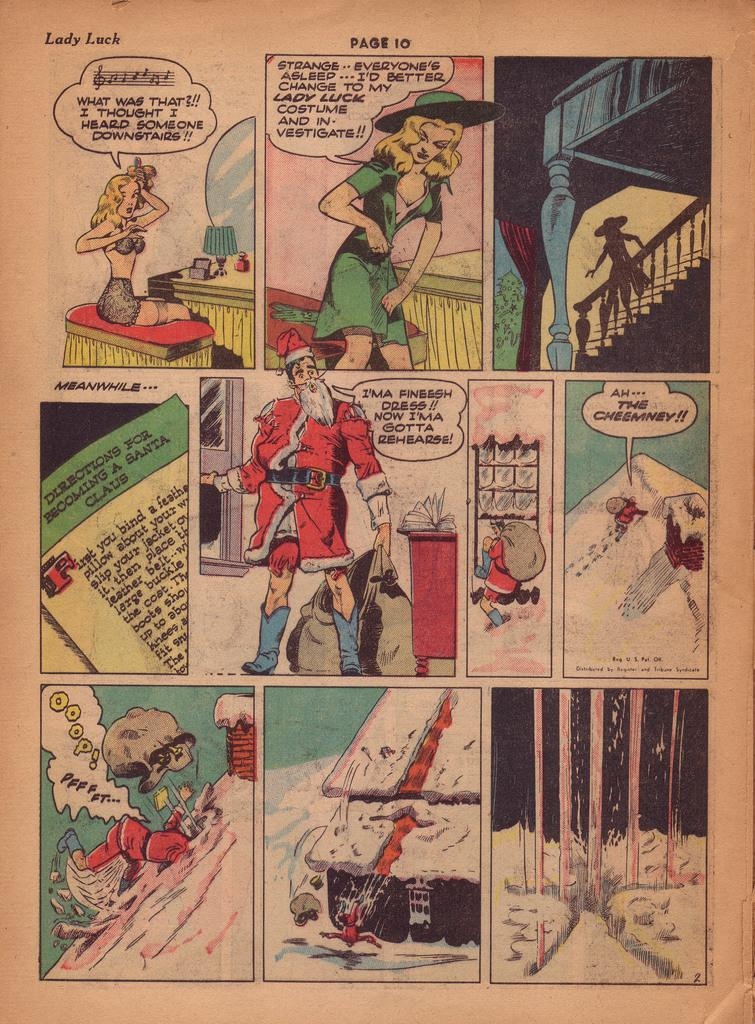<image>
Describe the image concisely. A page of comics with ten panels is titled Lady Luck. 